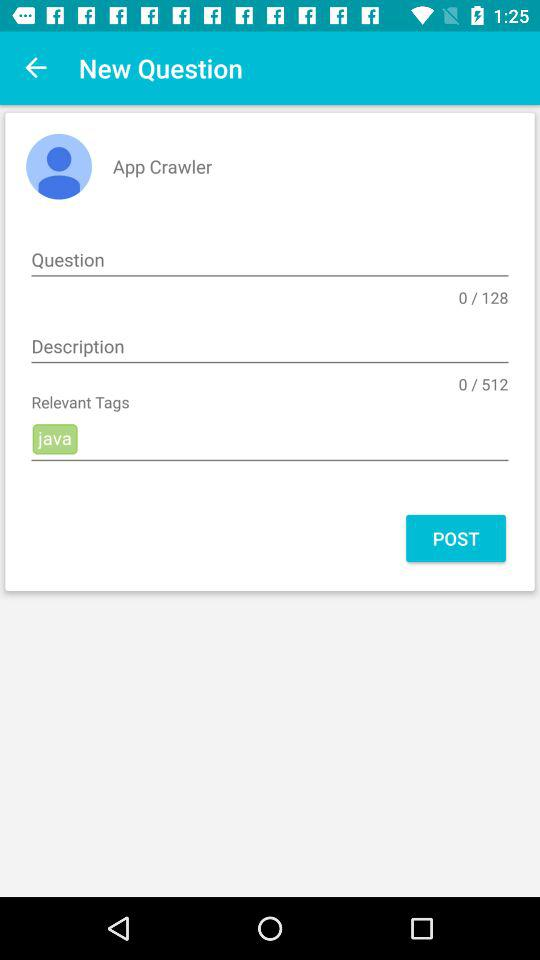What is the user's name? The user's name is App Crawler. 